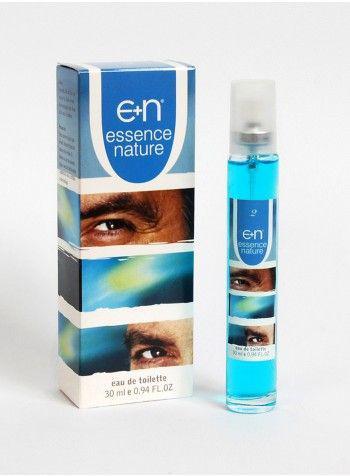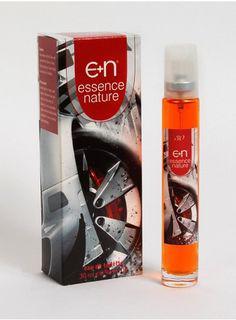The first image is the image on the left, the second image is the image on the right. Considering the images on both sides, is "The right image contains a slim container with blue liquid inside it." valid? Answer yes or no. No. 